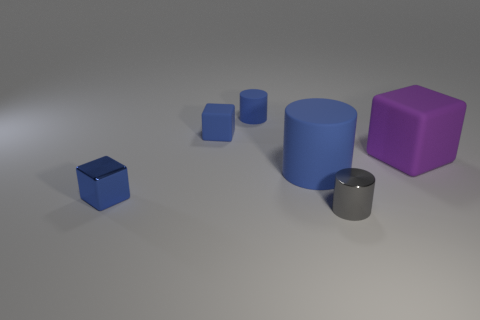There is a tiny object that is made of the same material as the gray cylinder; what is its color?
Ensure brevity in your answer.  Blue. Are there fewer rubber cylinders in front of the large rubber cube than large red rubber spheres?
Offer a terse response. No. The tiny blue thing that is the same material as the tiny blue cylinder is what shape?
Your answer should be compact. Cube. What number of metallic objects are small cylinders or gray objects?
Ensure brevity in your answer.  1. Are there an equal number of big things that are in front of the large rubber block and blue matte blocks?
Keep it short and to the point. Yes. Is the color of the matte cube that is to the left of the tiny gray metallic object the same as the metal cylinder?
Provide a short and direct response. No. There is a cube that is both behind the large blue matte cylinder and to the left of the purple rubber cube; what material is it?
Ensure brevity in your answer.  Rubber. Is there a block that is to the left of the tiny cylinder behind the gray cylinder?
Keep it short and to the point. Yes. Do the small blue cylinder and the purple cube have the same material?
Ensure brevity in your answer.  Yes. There is a tiny blue thing that is on the left side of the small matte cylinder and behind the big purple rubber block; what shape is it?
Keep it short and to the point. Cube. 